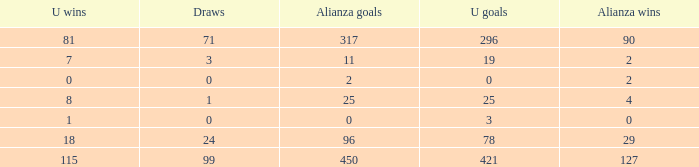Give me the full table as a dictionary. {'header': ['U wins', 'Draws', 'Alianza goals', 'U goals', 'Alianza wins'], 'rows': [['81', '71', '317', '296', '90'], ['7', '3', '11', '19', '2'], ['0', '0', '2', '0', '2'], ['8', '1', '25', '25', '4'], ['1', '0', '0', '3', '0'], ['18', '24', '96', '78', '29'], ['115', '99', '450', '421', '127']]} What is the sum of Alianza Wins, when Alianza Goals is "317, and when U Goals is greater than 296? None. 